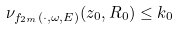Convert formula to latex. <formula><loc_0><loc_0><loc_500><loc_500>\nu _ { f _ { 2 m } ( \cdot , \omega , E ) } ( z _ { 0 } , R _ { 0 } ) \leq k _ { 0 }</formula> 